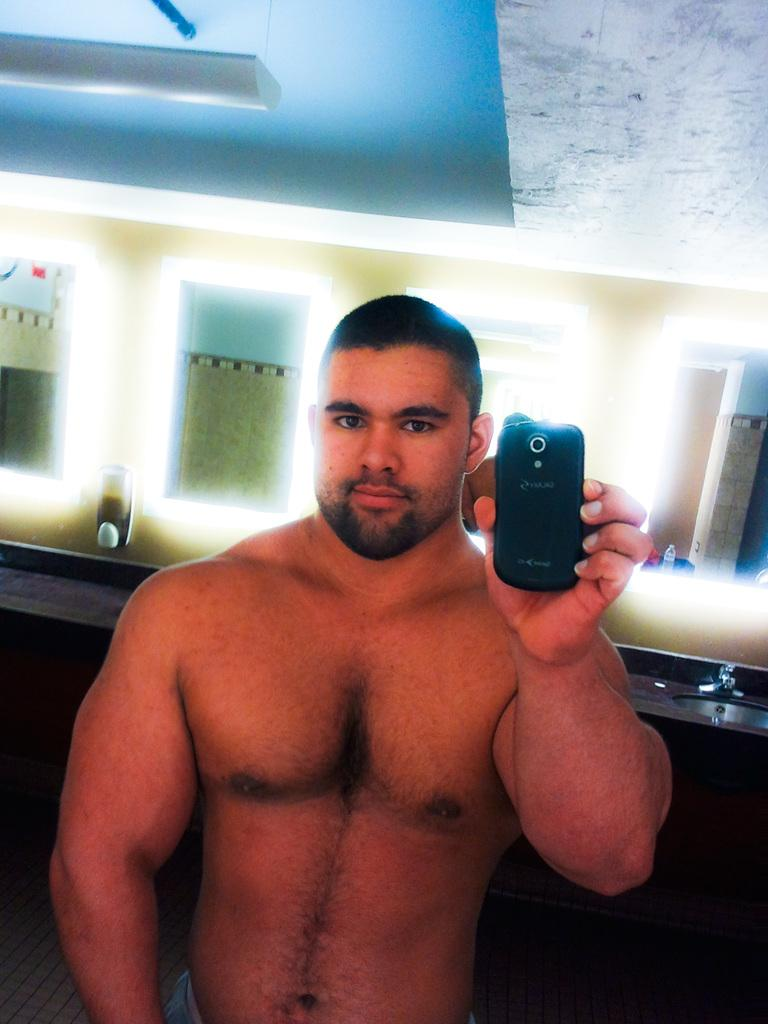What is the main subject of the image? The main subject of the image is a man. What is the man holding in his hands? The man is holding a camera phone in his hands. What can be seen in the background of the image? There are mirrors in the background of the image. How many guns can be seen in the image? There are no guns present in the image. What type of bikes are visible in the image? There are no bikes present in the image. 